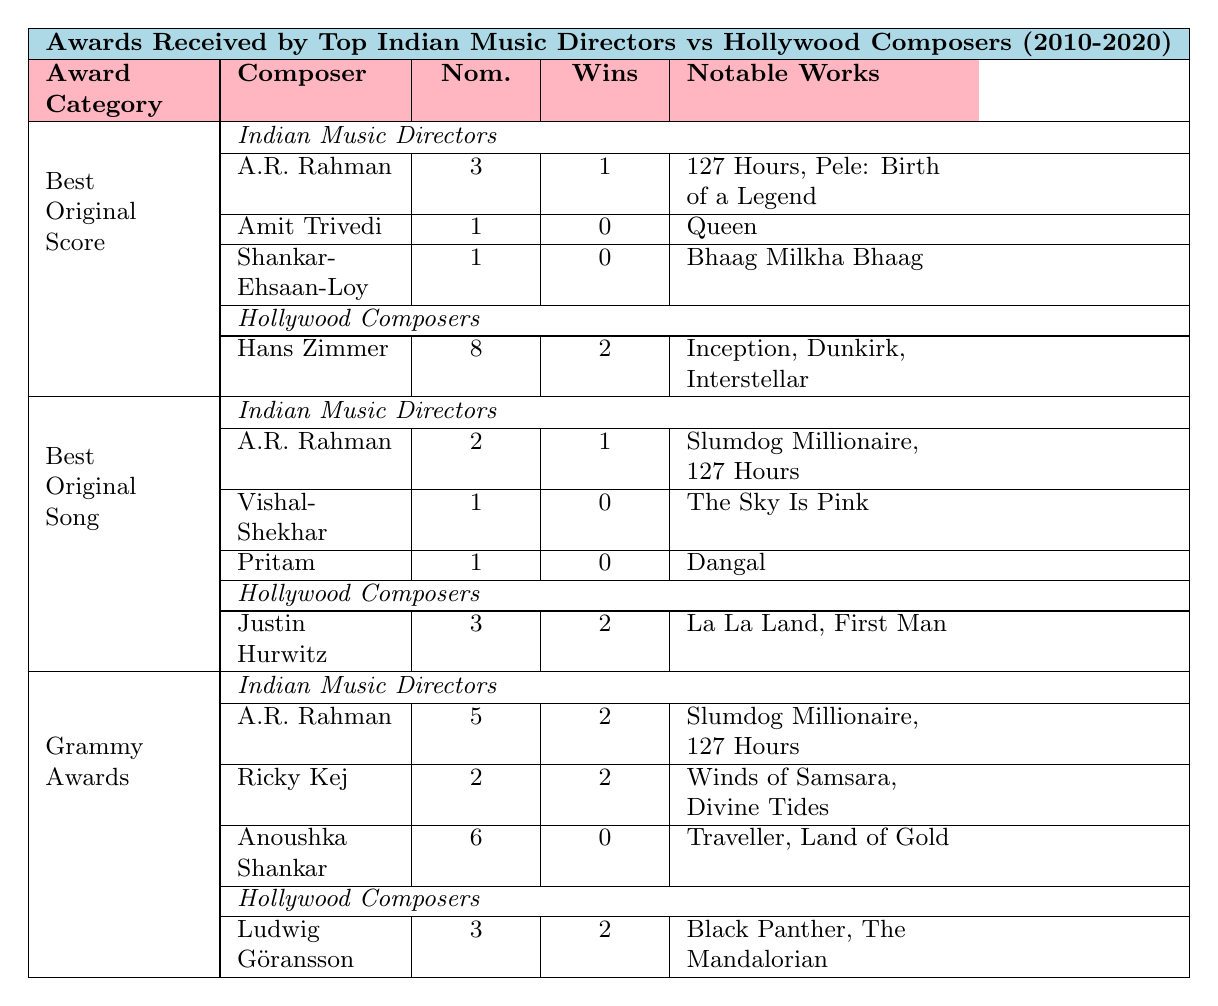What is the total number of nominations received by A.R. Rahman in all award categories? A.R. Rahman has received nominations in three categories: 3 nominations in Best Original Score, 2 nominations in Best Original Song, and 5 nominations in Grammy Awards. Summing these gives 3 + 2 + 5 = 10 nominations.
Answer: 10 How many wins does Hans Zimmer have across all award categories listed? Hans Zimmer has wins in one category: 2 wins in Best Original Score. He has no wins in Best Original Song or Grammy Awards. Thus, he has a total of 2 wins.
Answer: 2 Which Indian music director has the most Grammy nominations, and how many do they have? Anoushka Shankar has the most Grammy nominations with 6 nominations. The other two Indian music directors, A.R. Rahman and Ricky Kej, have 5 and 2 nominations, respectively.
Answer: Anoushka Shankar, 6 nominations Did Amit Trivedi win any awards in the Best Original Score category? Yes, according to the table, Amit Trivedi has 1 nomination in Best Original Score but has not won any, as his wins are listed as 0.
Answer: No What is the average number of wins for Indian music directors in the Grammy Awards category? The Indian music directors listed have 2 (A.R. Rahman) + 2 (Ricky Kej) + 0 (Anoushka Shankar) = 4 wins in total. There are three directors, so the average is 4 / 3 = 1.33.
Answer: 1.33 Which award category has the highest total nominations across both Indian music directors and Hollywood composers? In the Best Original Score category, there are 3 total nominations for Indian music directors (A.R. Rahman, Amit Trivedi, and Shankar-Ehsaan-Loy) and 8 nominations for Hollywood composers (Hans Zimmer, Alexandre Desplat, and John Williams), giving a total of 3 + 8 = 11 nominations. This is the highest total compared to the other categories.
Answer: Best Original Score, 11 nominations How does the number of total wins for A.R. Rahman compare to that of Justin Hurwitz? A.R. Rahman has a total of 1 win in Best Original Score and 1 win in Best Original Song, giving him 2 wins total. Justin Hurwitz has 2 wins in Best Original Song. They are equal in total wins, both having 2 wins.
Answer: Equal, 2 wins each Which Hollywood composer has the highest number of nominations in the Best Original Score category? Hans Zimmer has the highest number of nominations in the Best Original Score category with 8 nominations. Other composers listed in the same category have fewer nominations.
Answer: Hans Zimmer, 8 nominations What is the total number of wins for all Hollywood composers listed in the Best Original Song category? Justin Hurwitz has 2 wins, Lady Gaga has 1 win, and Kristen Anderson-Lopez & Robert Lopez have 2 wins. Adding these together gives a total of 2 + 1 + 2 = 5 wins.
Answer: 5 wins Which Indian music director's notable works in the Best Original Score category include "127 Hours"? A.R. Rahman’s notable works in the Best Original Score category include "127 Hours" as mentioned in the table.
Answer: A.R. Rahman What is the difference in the number of nominations between the top Indian music director and the top Hollywood composer in the Grammy Awards? A.R. Rahman has 5 nominations while Ludwig Göransson has 3 nominations. The difference is 5 - 3 = 2.
Answer: 2 nominations 